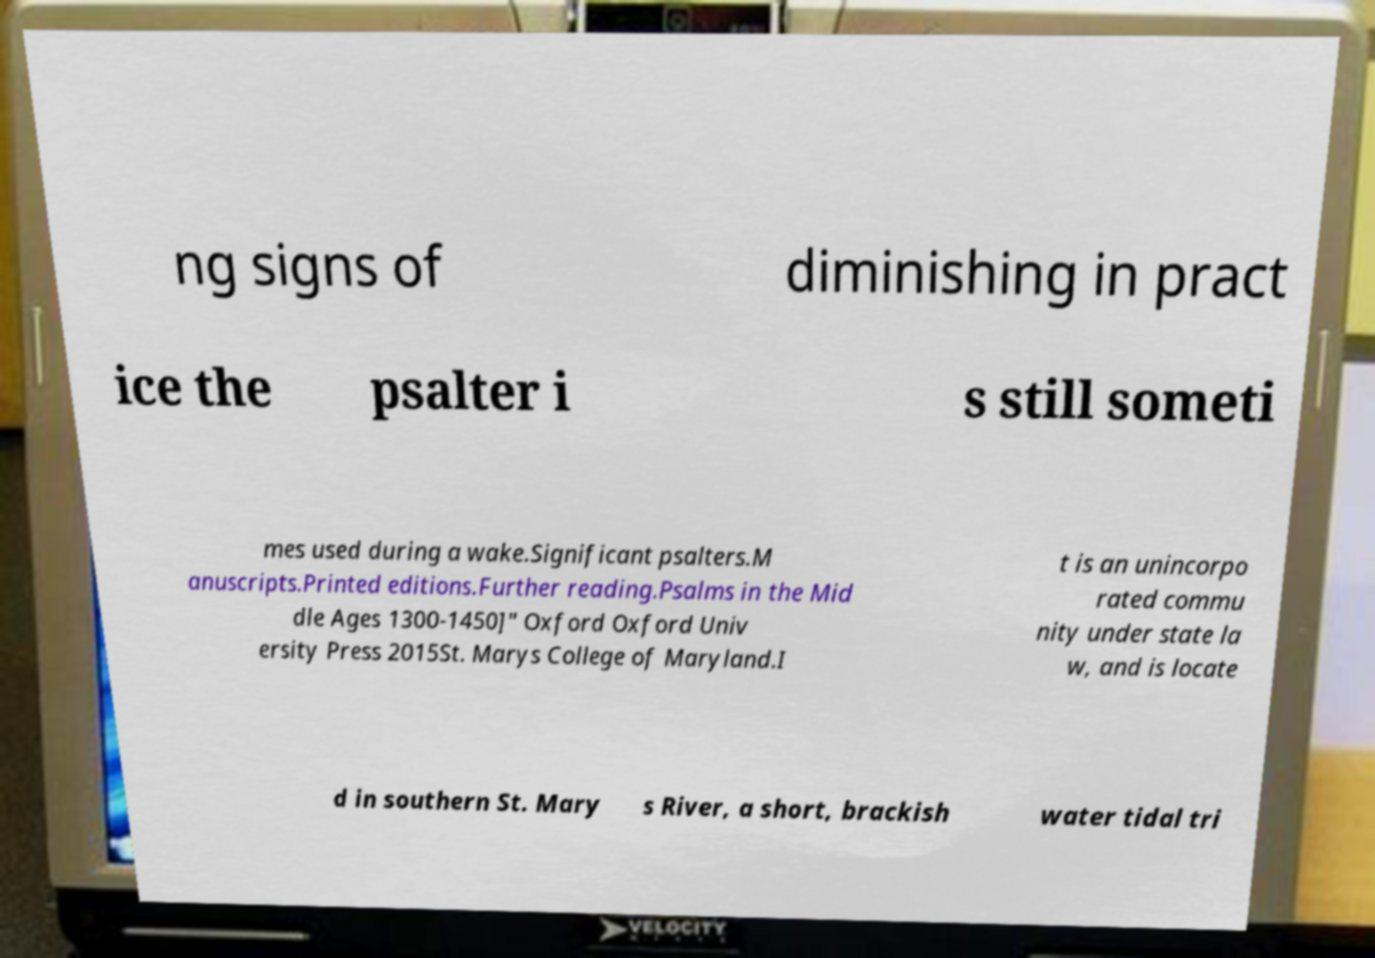Could you extract and type out the text from this image? ng signs of diminishing in pract ice the psalter i s still someti mes used during a wake.Significant psalters.M anuscripts.Printed editions.Further reading.Psalms in the Mid dle Ages 1300-1450]" Oxford Oxford Univ ersity Press 2015St. Marys College of Maryland.I t is an unincorpo rated commu nity under state la w, and is locate d in southern St. Mary s River, a short, brackish water tidal tri 